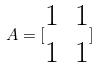<formula> <loc_0><loc_0><loc_500><loc_500>A = [ \begin{matrix} 1 & 1 \\ 1 & 1 \end{matrix} ]</formula> 